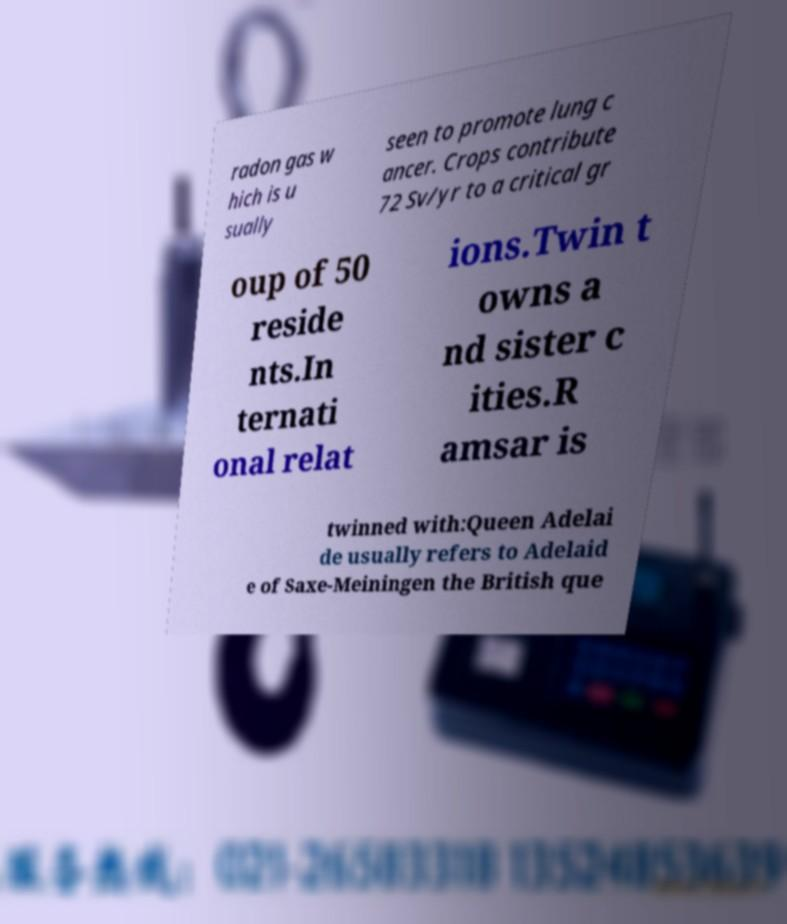Can you read and provide the text displayed in the image?This photo seems to have some interesting text. Can you extract and type it out for me? radon gas w hich is u sually seen to promote lung c ancer. Crops contribute 72 Sv/yr to a critical gr oup of 50 reside nts.In ternati onal relat ions.Twin t owns a nd sister c ities.R amsar is twinned with:Queen Adelai de usually refers to Adelaid e of Saxe-Meiningen the British que 